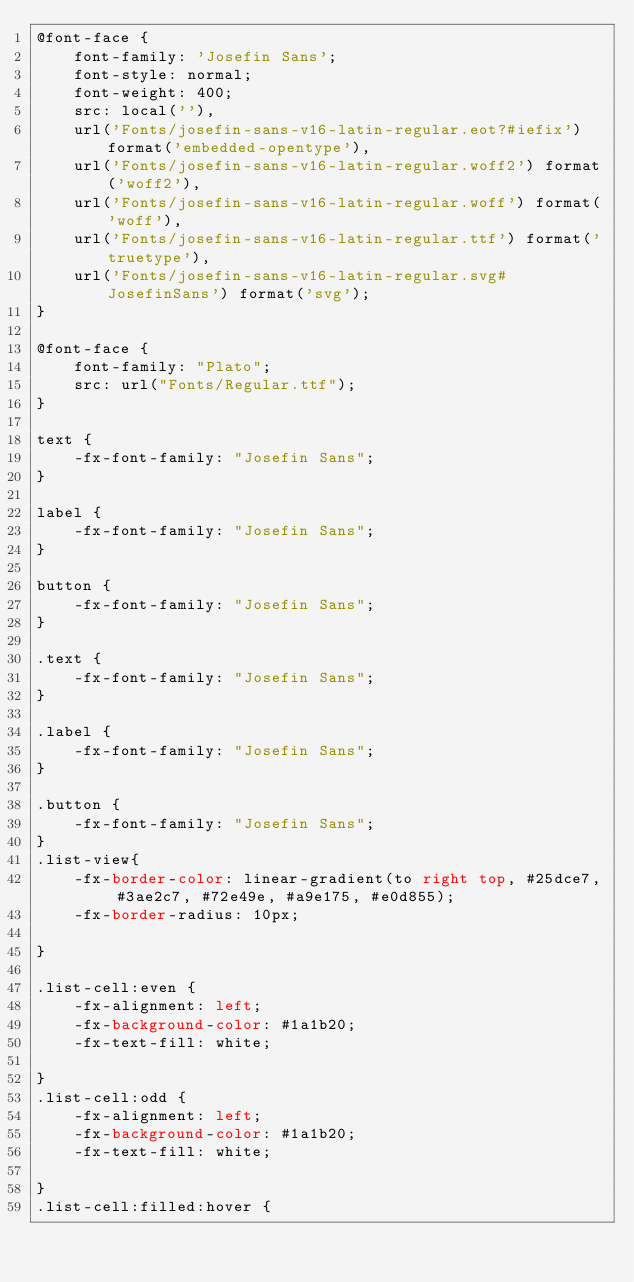<code> <loc_0><loc_0><loc_500><loc_500><_CSS_>@font-face {
    font-family: 'Josefin Sans';
    font-style: normal;
    font-weight: 400;
    src: local(''),
    url('Fonts/josefin-sans-v16-latin-regular.eot?#iefix') format('embedded-opentype'),
    url('Fonts/josefin-sans-v16-latin-regular.woff2') format('woff2'),
    url('Fonts/josefin-sans-v16-latin-regular.woff') format('woff'),
    url('Fonts/josefin-sans-v16-latin-regular.ttf') format('truetype'),
    url('Fonts/josefin-sans-v16-latin-regular.svg#JosefinSans') format('svg');
}

@font-face {
    font-family: "Plato";
    src: url("Fonts/Regular.ttf");
}

text {
    -fx-font-family: "Josefin Sans";
}

label {
    -fx-font-family: "Josefin Sans";
}

button {
    -fx-font-family: "Josefin Sans";
}

.text {
    -fx-font-family: "Josefin Sans";
}

.label {
    -fx-font-family: "Josefin Sans";
}

.button {
    -fx-font-family: "Josefin Sans";
}
.list-view{
    -fx-border-color: linear-gradient(to right top, #25dce7, #3ae2c7, #72e49e, #a9e175, #e0d855);
    -fx-border-radius: 10px;

}

.list-cell:even {
    -fx-alignment: left;
    -fx-background-color: #1a1b20;
    -fx-text-fill: white;

}
.list-cell:odd {
    -fx-alignment: left;
    -fx-background-color: #1a1b20;
    -fx-text-fill: white;

}
.list-cell:filled:hover {</code> 